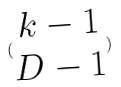<formula> <loc_0><loc_0><loc_500><loc_500>( \begin{matrix} k - 1 \\ D - 1 \end{matrix} )</formula> 